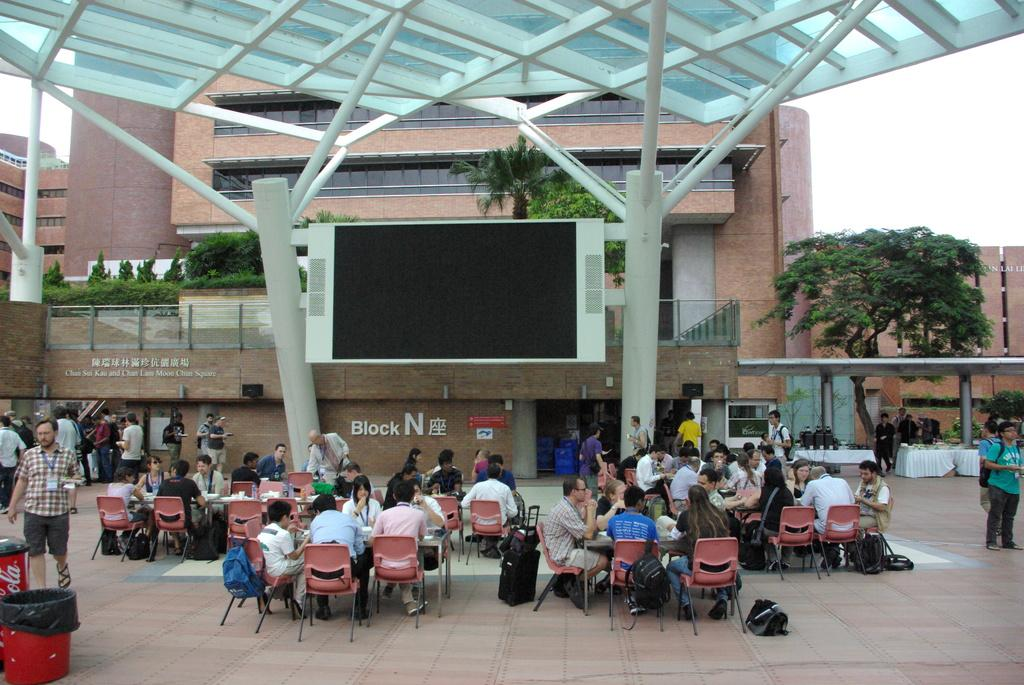What are the people in the image doing? There are people sitting on chairs and standing in the image. What objects are on the floor in the image? There are bins and bags on the floor. What can be seen in the background of the image? Buildings, people, plants, trees, and the sky are visible in the background of the image. Where is the calculator located in the image? There is no calculator present in the image. What type of wilderness can be seen in the background of the image? There is no wilderness visible in the image; it features a background with buildings, people, plants, trees, and the sky. 